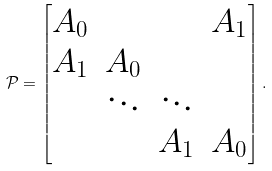<formula> <loc_0><loc_0><loc_500><loc_500>\mathcal { P } = \begin{bmatrix} A _ { 0 } & & & A _ { 1 } \\ A _ { 1 } & A _ { 0 } & & \\ & \ddots & \ddots & \\ & & A _ { 1 } & A _ { 0 } \end{bmatrix} .</formula> 